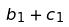Convert formula to latex. <formula><loc_0><loc_0><loc_500><loc_500>b _ { 1 } + c _ { 1 }</formula> 